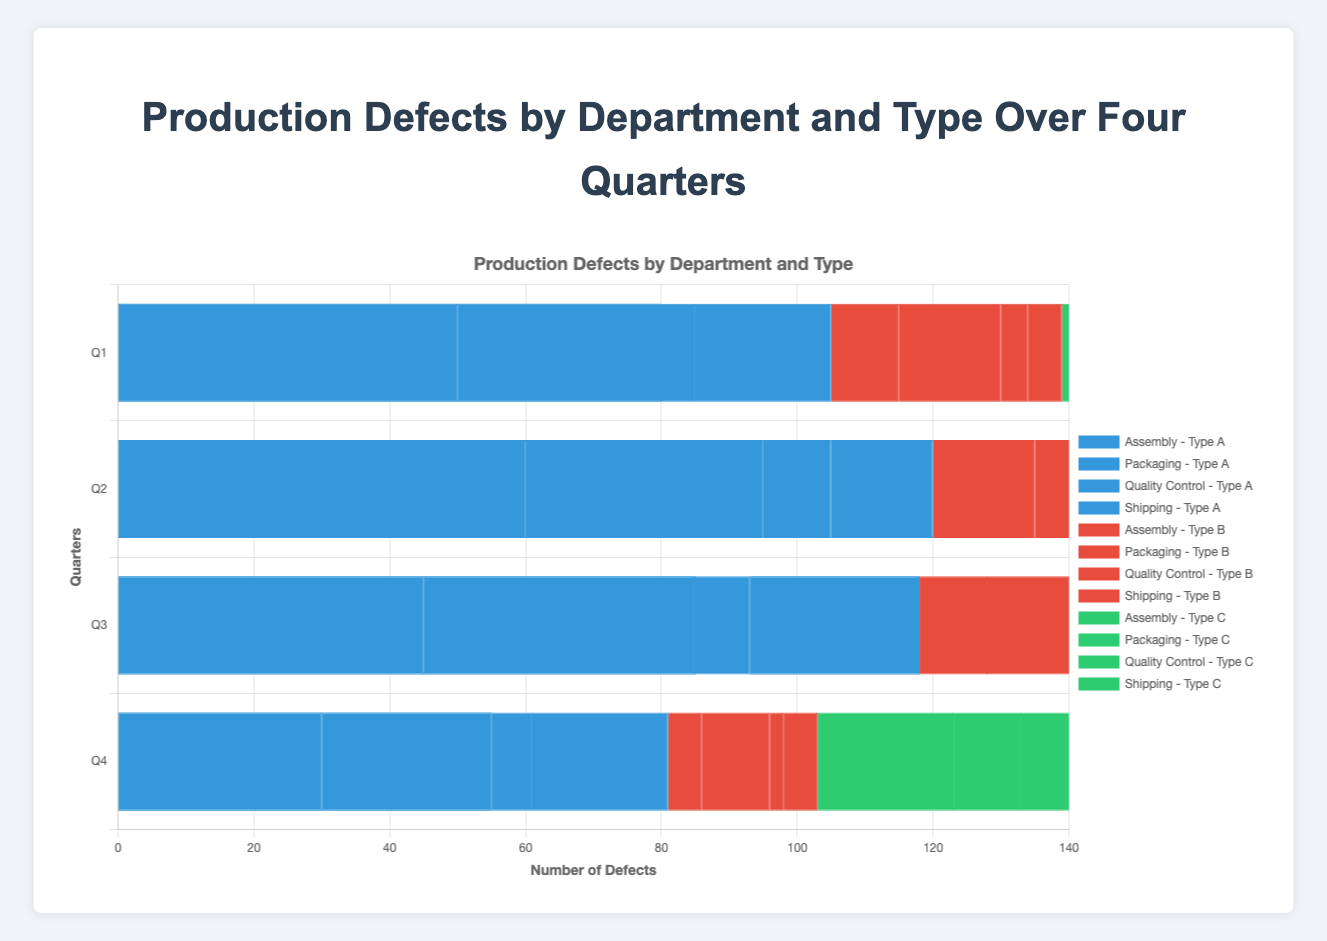What is the total number of Type A defects reported by the Assembly department over all four quarters? The total number of Type A defects reported by the Assembly department over four quarters is calculated as follows: 50 (Q1) + 60 (Q2) + 45 (Q3) + 30 (Q4) = 185
Answer: 185 Which department had the highest number of Type B defects in Q2? In Q2, Type B defects for each department are: Assembly (15), Packaging (10), Quality Control (5), and Shipping (10). Comparing these values, the Assembly department had the highest number of Type B defects in Q2.
Answer: Assembly Which quarter had the lowest total number of defects across all departments for Type C? Summing Type C defects for all departments in each quarter: Q1 (20+10+12+8=50), Q2 (25+20+8+10=63), Q3 (30+15+15+10=70), Q4 (20+10+10+12=52). Q1 has the lowest total with 50 defects.
Answer: Q1 Compare the total number of defects in Q4 between the Assembly and Packaging departments. Which one is higher? For Q4, total defects in Assembly: 30 (Type A) + 5 (Type B) + 20 (Type C) = 55. Total defects in Packaging: 25 (Type A) + 10 (Type B) + 10 (Type C) = 45. Assembly has a higher total.
Answer: Assembly Is the number of Type B defects for Quality Control in Q3 greater than the number of Type C defects for Shipping in Q3? In Q3, Type B defects for Quality Control are 6 and Type C defects for Shipping are 10. Comparing these values, 6 is not greater than 10.
Answer: No Which department had the most significant decrease in Type A defects from Q1 to Q4? Calculating the decrease for Type A defects from Q1 to Q4: Assembly (50-30=20), Packaging (30-25=5), Quality Control (5-6=-1, increase), Shipping (20-20=0). The Assembly department had the largest decrease with 20.
Answer: Assembly In which quarter did the Packaging department report the highest number of total defects? Summing total defects per quarter for Packaging: Q1 (30+15+10=55), Q2 (35+10+20=65), Q3 (40+20+15=75), Q4 (25+10+10=45). The highest number is in Q3 with 75 total defects.
Answer: Q3 What is the combined total number of Type C defects reported by all departments in Q2 and Q4? Summing Type C defects for each department in Q2 (25+20+8+10=63) and Q4 (20+10+10+12=52). Combined total: 63 (Q2) + 52 (Q4) = 115
Answer: 115 